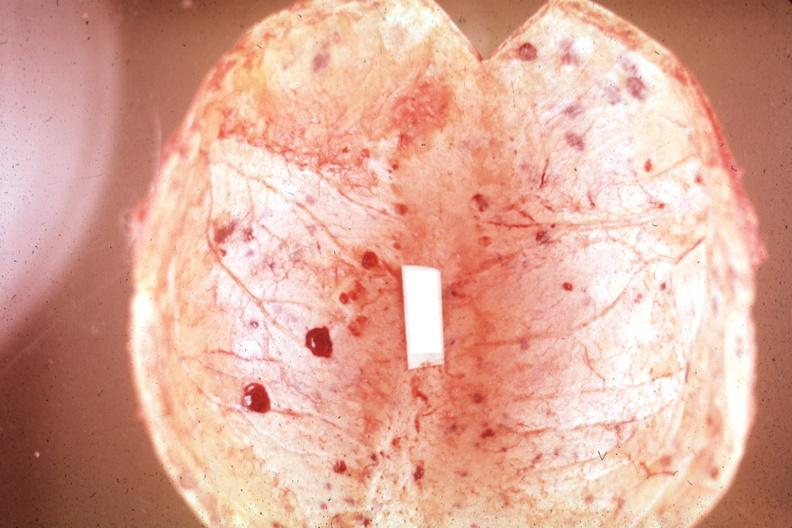what are easily seen?
Answer the question using a single word or phrase. Multiple and typical lesions 